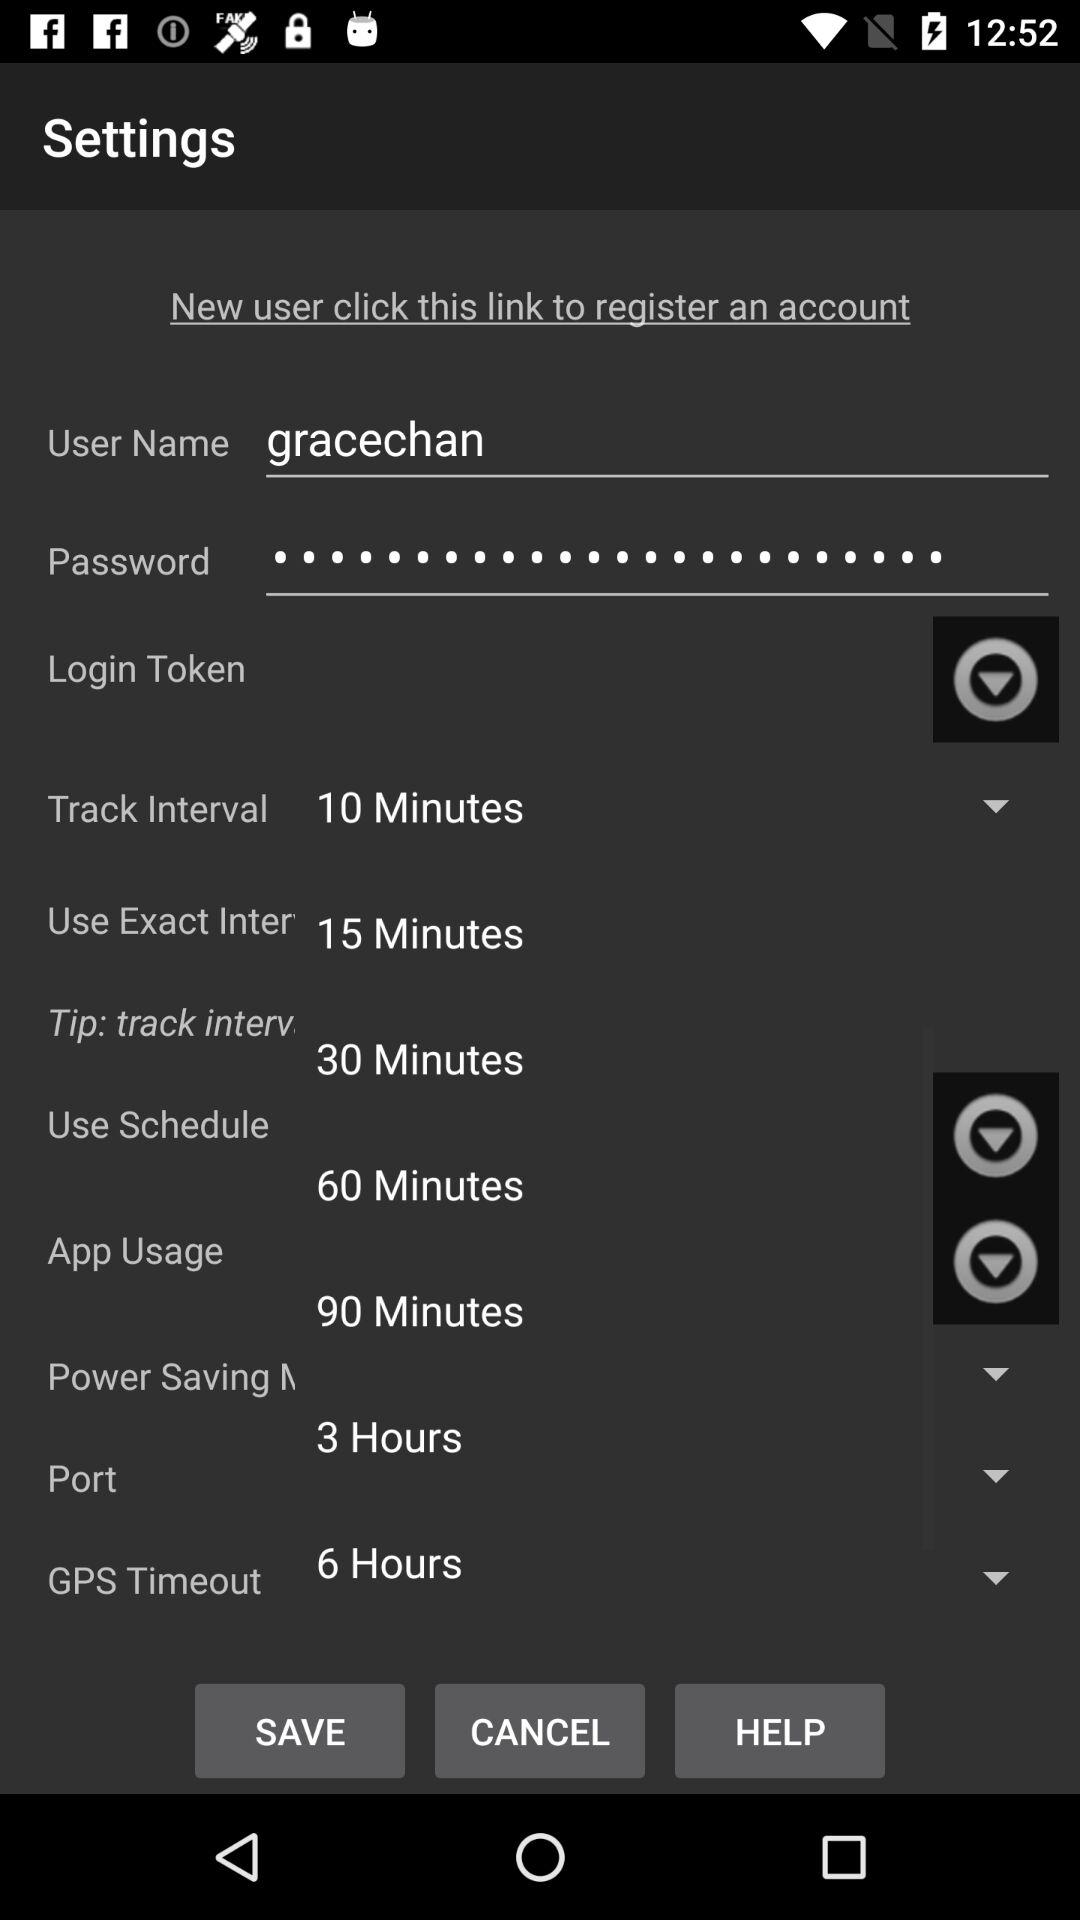What is the app usage time?
When the provided information is insufficient, respond with <no answer>. <no answer> 